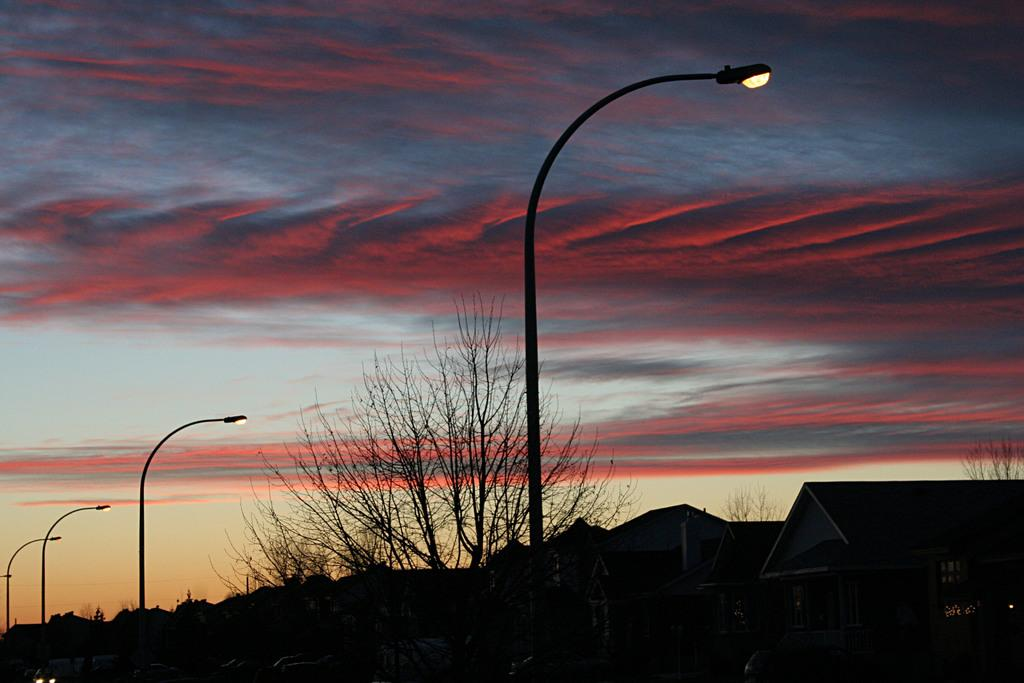What structures with lights are present in the image? There are poles with lights in the image. What type of natural vegetation is visible in the image? There are trees in the image. What type of buildings can be seen in the image? There are houses in the image. What is visible in the background of the image? The sky is visible in the image. How many letters of approval are visible in the image? There are no letters of approval present in the image. Are there any brothers depicted in the image? There is no reference to any brothers in the image. 